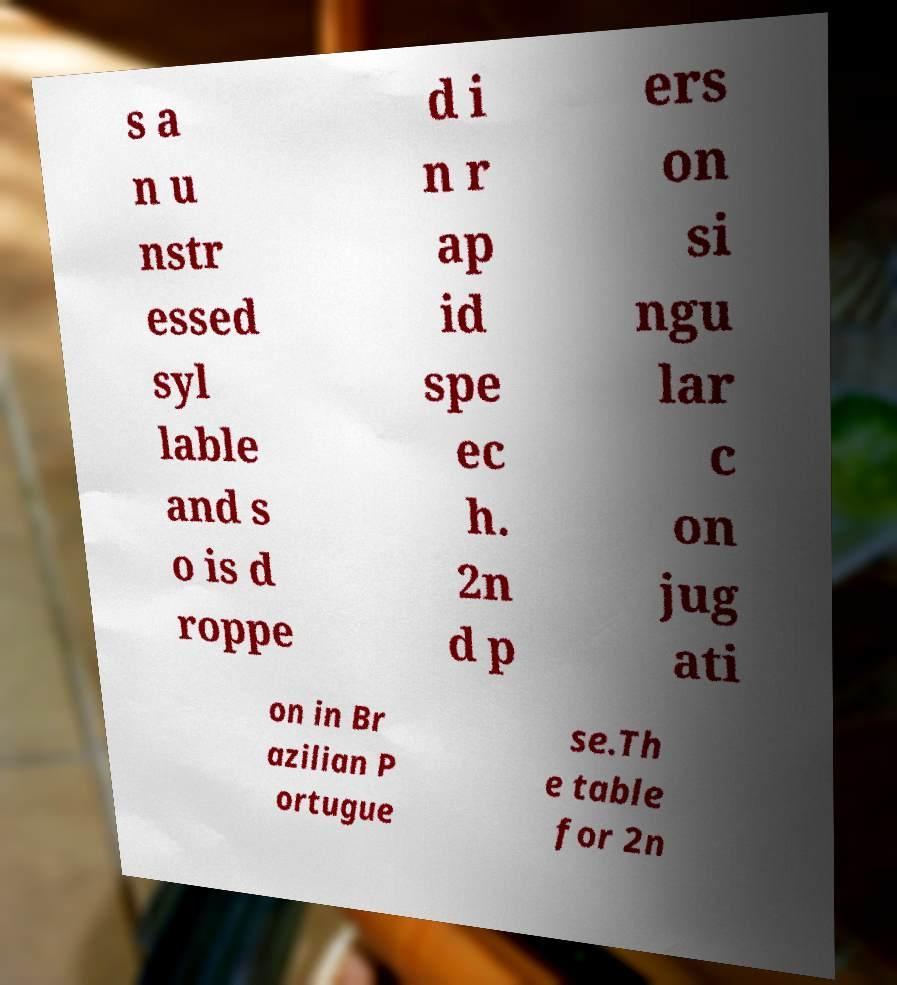Could you extract and type out the text from this image? s a n u nstr essed syl lable and s o is d roppe d i n r ap id spe ec h. 2n d p ers on si ngu lar c on jug ati on in Br azilian P ortugue se.Th e table for 2n 